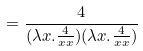Convert formula to latex. <formula><loc_0><loc_0><loc_500><loc_500>= \frac { 4 } { ( \lambda x . \frac { 4 } { x x } ) ( \lambda x . \frac { 4 } { x x } ) }</formula> 